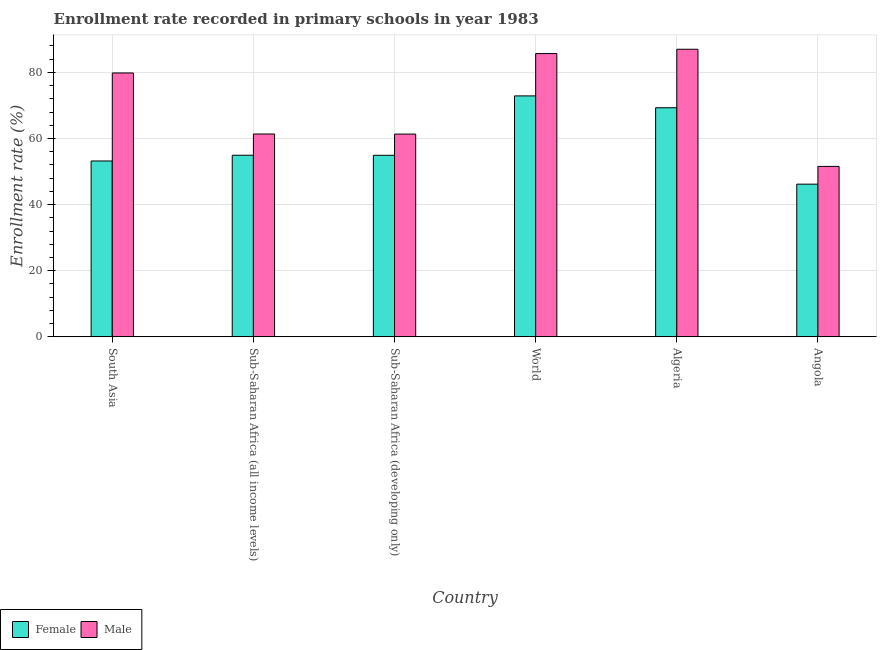How many different coloured bars are there?
Keep it short and to the point. 2. How many groups of bars are there?
Your response must be concise. 6. Are the number of bars on each tick of the X-axis equal?
Offer a terse response. Yes. How many bars are there on the 1st tick from the left?
Provide a succinct answer. 2. How many bars are there on the 3rd tick from the right?
Give a very brief answer. 2. What is the label of the 5th group of bars from the left?
Keep it short and to the point. Algeria. In how many cases, is the number of bars for a given country not equal to the number of legend labels?
Give a very brief answer. 0. What is the enrollment rate of male students in World?
Make the answer very short. 85.68. Across all countries, what is the maximum enrollment rate of male students?
Make the answer very short. 86.98. Across all countries, what is the minimum enrollment rate of female students?
Ensure brevity in your answer.  46.18. In which country was the enrollment rate of male students maximum?
Your answer should be very brief. Algeria. In which country was the enrollment rate of male students minimum?
Make the answer very short. Angola. What is the total enrollment rate of male students in the graph?
Your answer should be very brief. 426.71. What is the difference between the enrollment rate of male students in Angola and that in Sub-Saharan Africa (all income levels)?
Offer a very short reply. -9.79. What is the difference between the enrollment rate of female students in Algeria and the enrollment rate of male students in World?
Provide a succinct answer. -16.39. What is the average enrollment rate of female students per country?
Provide a short and direct response. 58.56. What is the difference between the enrollment rate of female students and enrollment rate of male students in Angola?
Your answer should be very brief. -5.37. What is the ratio of the enrollment rate of female students in Algeria to that in World?
Provide a short and direct response. 0.95. What is the difference between the highest and the second highest enrollment rate of male students?
Offer a terse response. 1.3. What is the difference between the highest and the lowest enrollment rate of female students?
Keep it short and to the point. 26.69. In how many countries, is the enrollment rate of male students greater than the average enrollment rate of male students taken over all countries?
Your response must be concise. 3. What does the 1st bar from the left in Angola represents?
Offer a very short reply. Female. How many bars are there?
Keep it short and to the point. 12. How many countries are there in the graph?
Offer a very short reply. 6. What is the difference between two consecutive major ticks on the Y-axis?
Your response must be concise. 20. Does the graph contain any zero values?
Your answer should be compact. No. Does the graph contain grids?
Give a very brief answer. Yes. How many legend labels are there?
Provide a succinct answer. 2. What is the title of the graph?
Give a very brief answer. Enrollment rate recorded in primary schools in year 1983. What is the label or title of the Y-axis?
Offer a terse response. Enrollment rate (%). What is the Enrollment rate (%) of Female in South Asia?
Provide a short and direct response. 53.19. What is the Enrollment rate (%) of Male in South Asia?
Provide a succinct answer. 79.81. What is the Enrollment rate (%) of Female in Sub-Saharan Africa (all income levels)?
Offer a very short reply. 54.93. What is the Enrollment rate (%) in Male in Sub-Saharan Africa (all income levels)?
Offer a terse response. 61.35. What is the Enrollment rate (%) in Female in Sub-Saharan Africa (developing only)?
Provide a short and direct response. 54.91. What is the Enrollment rate (%) in Male in Sub-Saharan Africa (developing only)?
Offer a very short reply. 61.33. What is the Enrollment rate (%) in Female in World?
Your response must be concise. 72.87. What is the Enrollment rate (%) in Male in World?
Provide a succinct answer. 85.68. What is the Enrollment rate (%) in Female in Algeria?
Give a very brief answer. 69.29. What is the Enrollment rate (%) of Male in Algeria?
Offer a very short reply. 86.98. What is the Enrollment rate (%) of Female in Angola?
Keep it short and to the point. 46.18. What is the Enrollment rate (%) of Male in Angola?
Offer a very short reply. 51.55. Across all countries, what is the maximum Enrollment rate (%) of Female?
Your answer should be compact. 72.87. Across all countries, what is the maximum Enrollment rate (%) in Male?
Keep it short and to the point. 86.98. Across all countries, what is the minimum Enrollment rate (%) of Female?
Your response must be concise. 46.18. Across all countries, what is the minimum Enrollment rate (%) of Male?
Your answer should be very brief. 51.55. What is the total Enrollment rate (%) in Female in the graph?
Keep it short and to the point. 351.37. What is the total Enrollment rate (%) in Male in the graph?
Provide a succinct answer. 426.71. What is the difference between the Enrollment rate (%) of Female in South Asia and that in Sub-Saharan Africa (all income levels)?
Keep it short and to the point. -1.74. What is the difference between the Enrollment rate (%) in Male in South Asia and that in Sub-Saharan Africa (all income levels)?
Provide a succinct answer. 18.46. What is the difference between the Enrollment rate (%) in Female in South Asia and that in Sub-Saharan Africa (developing only)?
Make the answer very short. -1.71. What is the difference between the Enrollment rate (%) of Male in South Asia and that in Sub-Saharan Africa (developing only)?
Your response must be concise. 18.48. What is the difference between the Enrollment rate (%) in Female in South Asia and that in World?
Your response must be concise. -19.68. What is the difference between the Enrollment rate (%) of Male in South Asia and that in World?
Keep it short and to the point. -5.87. What is the difference between the Enrollment rate (%) in Female in South Asia and that in Algeria?
Provide a succinct answer. -16.1. What is the difference between the Enrollment rate (%) in Male in South Asia and that in Algeria?
Your answer should be compact. -7.17. What is the difference between the Enrollment rate (%) in Female in South Asia and that in Angola?
Make the answer very short. 7.01. What is the difference between the Enrollment rate (%) in Male in South Asia and that in Angola?
Provide a short and direct response. 28.26. What is the difference between the Enrollment rate (%) of Female in Sub-Saharan Africa (all income levels) and that in Sub-Saharan Africa (developing only)?
Make the answer very short. 0.02. What is the difference between the Enrollment rate (%) of Male in Sub-Saharan Africa (all income levels) and that in Sub-Saharan Africa (developing only)?
Offer a very short reply. 0.02. What is the difference between the Enrollment rate (%) of Female in Sub-Saharan Africa (all income levels) and that in World?
Provide a succinct answer. -17.94. What is the difference between the Enrollment rate (%) in Male in Sub-Saharan Africa (all income levels) and that in World?
Provide a succinct answer. -24.33. What is the difference between the Enrollment rate (%) in Female in Sub-Saharan Africa (all income levels) and that in Algeria?
Make the answer very short. -14.36. What is the difference between the Enrollment rate (%) of Male in Sub-Saharan Africa (all income levels) and that in Algeria?
Make the answer very short. -25.63. What is the difference between the Enrollment rate (%) in Female in Sub-Saharan Africa (all income levels) and that in Angola?
Your response must be concise. 8.75. What is the difference between the Enrollment rate (%) of Male in Sub-Saharan Africa (all income levels) and that in Angola?
Offer a very short reply. 9.79. What is the difference between the Enrollment rate (%) in Female in Sub-Saharan Africa (developing only) and that in World?
Your response must be concise. -17.97. What is the difference between the Enrollment rate (%) in Male in Sub-Saharan Africa (developing only) and that in World?
Ensure brevity in your answer.  -24.35. What is the difference between the Enrollment rate (%) in Female in Sub-Saharan Africa (developing only) and that in Algeria?
Give a very brief answer. -14.38. What is the difference between the Enrollment rate (%) of Male in Sub-Saharan Africa (developing only) and that in Algeria?
Offer a terse response. -25.65. What is the difference between the Enrollment rate (%) of Female in Sub-Saharan Africa (developing only) and that in Angola?
Ensure brevity in your answer.  8.73. What is the difference between the Enrollment rate (%) in Male in Sub-Saharan Africa (developing only) and that in Angola?
Provide a succinct answer. 9.78. What is the difference between the Enrollment rate (%) in Female in World and that in Algeria?
Offer a terse response. 3.58. What is the difference between the Enrollment rate (%) of Male in World and that in Algeria?
Your answer should be very brief. -1.3. What is the difference between the Enrollment rate (%) of Female in World and that in Angola?
Make the answer very short. 26.69. What is the difference between the Enrollment rate (%) of Male in World and that in Angola?
Your answer should be compact. 34.12. What is the difference between the Enrollment rate (%) of Female in Algeria and that in Angola?
Ensure brevity in your answer.  23.11. What is the difference between the Enrollment rate (%) in Male in Algeria and that in Angola?
Keep it short and to the point. 35.43. What is the difference between the Enrollment rate (%) of Female in South Asia and the Enrollment rate (%) of Male in Sub-Saharan Africa (all income levels)?
Your answer should be compact. -8.16. What is the difference between the Enrollment rate (%) in Female in South Asia and the Enrollment rate (%) in Male in Sub-Saharan Africa (developing only)?
Keep it short and to the point. -8.14. What is the difference between the Enrollment rate (%) in Female in South Asia and the Enrollment rate (%) in Male in World?
Provide a short and direct response. -32.49. What is the difference between the Enrollment rate (%) in Female in South Asia and the Enrollment rate (%) in Male in Algeria?
Your answer should be very brief. -33.79. What is the difference between the Enrollment rate (%) in Female in South Asia and the Enrollment rate (%) in Male in Angola?
Ensure brevity in your answer.  1.64. What is the difference between the Enrollment rate (%) in Female in Sub-Saharan Africa (all income levels) and the Enrollment rate (%) in Male in Sub-Saharan Africa (developing only)?
Your answer should be compact. -6.4. What is the difference between the Enrollment rate (%) in Female in Sub-Saharan Africa (all income levels) and the Enrollment rate (%) in Male in World?
Your response must be concise. -30.75. What is the difference between the Enrollment rate (%) of Female in Sub-Saharan Africa (all income levels) and the Enrollment rate (%) of Male in Algeria?
Give a very brief answer. -32.05. What is the difference between the Enrollment rate (%) of Female in Sub-Saharan Africa (all income levels) and the Enrollment rate (%) of Male in Angola?
Keep it short and to the point. 3.37. What is the difference between the Enrollment rate (%) of Female in Sub-Saharan Africa (developing only) and the Enrollment rate (%) of Male in World?
Offer a very short reply. -30.77. What is the difference between the Enrollment rate (%) of Female in Sub-Saharan Africa (developing only) and the Enrollment rate (%) of Male in Algeria?
Your answer should be compact. -32.07. What is the difference between the Enrollment rate (%) of Female in Sub-Saharan Africa (developing only) and the Enrollment rate (%) of Male in Angola?
Keep it short and to the point. 3.35. What is the difference between the Enrollment rate (%) in Female in World and the Enrollment rate (%) in Male in Algeria?
Your answer should be compact. -14.11. What is the difference between the Enrollment rate (%) of Female in World and the Enrollment rate (%) of Male in Angola?
Provide a succinct answer. 21.32. What is the difference between the Enrollment rate (%) of Female in Algeria and the Enrollment rate (%) of Male in Angola?
Your answer should be very brief. 17.74. What is the average Enrollment rate (%) in Female per country?
Your response must be concise. 58.56. What is the average Enrollment rate (%) of Male per country?
Give a very brief answer. 71.12. What is the difference between the Enrollment rate (%) in Female and Enrollment rate (%) in Male in South Asia?
Offer a terse response. -26.62. What is the difference between the Enrollment rate (%) in Female and Enrollment rate (%) in Male in Sub-Saharan Africa (all income levels)?
Your answer should be very brief. -6.42. What is the difference between the Enrollment rate (%) in Female and Enrollment rate (%) in Male in Sub-Saharan Africa (developing only)?
Keep it short and to the point. -6.42. What is the difference between the Enrollment rate (%) in Female and Enrollment rate (%) in Male in World?
Your answer should be compact. -12.81. What is the difference between the Enrollment rate (%) of Female and Enrollment rate (%) of Male in Algeria?
Give a very brief answer. -17.69. What is the difference between the Enrollment rate (%) in Female and Enrollment rate (%) in Male in Angola?
Your response must be concise. -5.37. What is the ratio of the Enrollment rate (%) in Female in South Asia to that in Sub-Saharan Africa (all income levels)?
Ensure brevity in your answer.  0.97. What is the ratio of the Enrollment rate (%) in Male in South Asia to that in Sub-Saharan Africa (all income levels)?
Provide a succinct answer. 1.3. What is the ratio of the Enrollment rate (%) in Female in South Asia to that in Sub-Saharan Africa (developing only)?
Keep it short and to the point. 0.97. What is the ratio of the Enrollment rate (%) in Male in South Asia to that in Sub-Saharan Africa (developing only)?
Your response must be concise. 1.3. What is the ratio of the Enrollment rate (%) in Female in South Asia to that in World?
Give a very brief answer. 0.73. What is the ratio of the Enrollment rate (%) of Male in South Asia to that in World?
Provide a succinct answer. 0.93. What is the ratio of the Enrollment rate (%) in Female in South Asia to that in Algeria?
Provide a short and direct response. 0.77. What is the ratio of the Enrollment rate (%) in Male in South Asia to that in Algeria?
Offer a very short reply. 0.92. What is the ratio of the Enrollment rate (%) of Female in South Asia to that in Angola?
Offer a very short reply. 1.15. What is the ratio of the Enrollment rate (%) of Male in South Asia to that in Angola?
Offer a very short reply. 1.55. What is the ratio of the Enrollment rate (%) of Male in Sub-Saharan Africa (all income levels) to that in Sub-Saharan Africa (developing only)?
Your answer should be very brief. 1. What is the ratio of the Enrollment rate (%) in Female in Sub-Saharan Africa (all income levels) to that in World?
Keep it short and to the point. 0.75. What is the ratio of the Enrollment rate (%) in Male in Sub-Saharan Africa (all income levels) to that in World?
Ensure brevity in your answer.  0.72. What is the ratio of the Enrollment rate (%) of Female in Sub-Saharan Africa (all income levels) to that in Algeria?
Ensure brevity in your answer.  0.79. What is the ratio of the Enrollment rate (%) of Male in Sub-Saharan Africa (all income levels) to that in Algeria?
Provide a short and direct response. 0.71. What is the ratio of the Enrollment rate (%) in Female in Sub-Saharan Africa (all income levels) to that in Angola?
Your response must be concise. 1.19. What is the ratio of the Enrollment rate (%) in Male in Sub-Saharan Africa (all income levels) to that in Angola?
Provide a short and direct response. 1.19. What is the ratio of the Enrollment rate (%) of Female in Sub-Saharan Africa (developing only) to that in World?
Your answer should be compact. 0.75. What is the ratio of the Enrollment rate (%) in Male in Sub-Saharan Africa (developing only) to that in World?
Give a very brief answer. 0.72. What is the ratio of the Enrollment rate (%) in Female in Sub-Saharan Africa (developing only) to that in Algeria?
Your answer should be compact. 0.79. What is the ratio of the Enrollment rate (%) of Male in Sub-Saharan Africa (developing only) to that in Algeria?
Ensure brevity in your answer.  0.71. What is the ratio of the Enrollment rate (%) in Female in Sub-Saharan Africa (developing only) to that in Angola?
Give a very brief answer. 1.19. What is the ratio of the Enrollment rate (%) in Male in Sub-Saharan Africa (developing only) to that in Angola?
Your answer should be compact. 1.19. What is the ratio of the Enrollment rate (%) in Female in World to that in Algeria?
Offer a terse response. 1.05. What is the ratio of the Enrollment rate (%) in Female in World to that in Angola?
Keep it short and to the point. 1.58. What is the ratio of the Enrollment rate (%) of Male in World to that in Angola?
Offer a terse response. 1.66. What is the ratio of the Enrollment rate (%) of Female in Algeria to that in Angola?
Your response must be concise. 1.5. What is the ratio of the Enrollment rate (%) in Male in Algeria to that in Angola?
Provide a succinct answer. 1.69. What is the difference between the highest and the second highest Enrollment rate (%) in Female?
Make the answer very short. 3.58. What is the difference between the highest and the second highest Enrollment rate (%) in Male?
Your answer should be compact. 1.3. What is the difference between the highest and the lowest Enrollment rate (%) of Female?
Ensure brevity in your answer.  26.69. What is the difference between the highest and the lowest Enrollment rate (%) in Male?
Give a very brief answer. 35.43. 